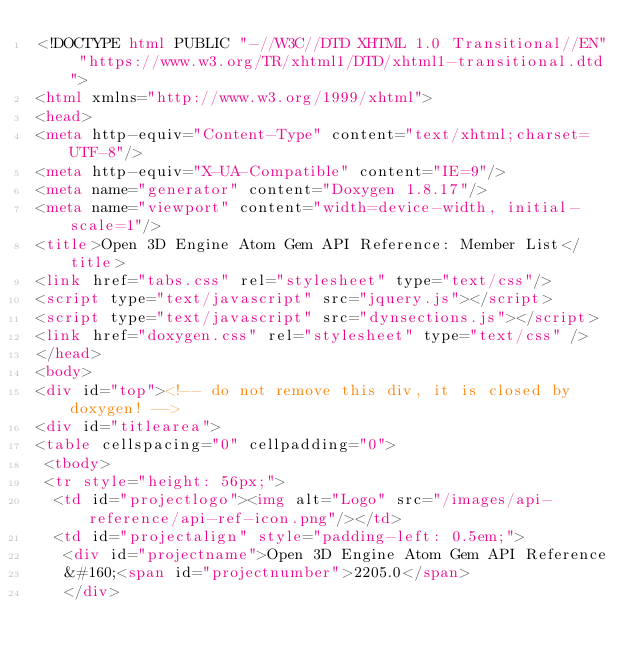Convert code to text. <code><loc_0><loc_0><loc_500><loc_500><_HTML_><!DOCTYPE html PUBLIC "-//W3C//DTD XHTML 1.0 Transitional//EN" "https://www.w3.org/TR/xhtml1/DTD/xhtml1-transitional.dtd">
<html xmlns="http://www.w3.org/1999/xhtml">
<head>
<meta http-equiv="Content-Type" content="text/xhtml;charset=UTF-8"/>
<meta http-equiv="X-UA-Compatible" content="IE=9"/>
<meta name="generator" content="Doxygen 1.8.17"/>
<meta name="viewport" content="width=device-width, initial-scale=1"/>
<title>Open 3D Engine Atom Gem API Reference: Member List</title>
<link href="tabs.css" rel="stylesheet" type="text/css"/>
<script type="text/javascript" src="jquery.js"></script>
<script type="text/javascript" src="dynsections.js"></script>
<link href="doxygen.css" rel="stylesheet" type="text/css" />
</head>
<body>
<div id="top"><!-- do not remove this div, it is closed by doxygen! -->
<div id="titlearea">
<table cellspacing="0" cellpadding="0">
 <tbody>
 <tr style="height: 56px;">
  <td id="projectlogo"><img alt="Logo" src="/images/api-reference/api-ref-icon.png"/></td>
  <td id="projectalign" style="padding-left: 0.5em;">
   <div id="projectname">Open 3D Engine Atom Gem API Reference
   &#160;<span id="projectnumber">2205.0</span>
   </div></code> 